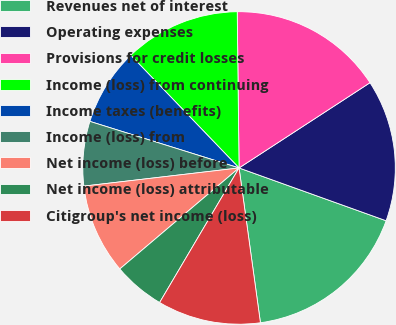Convert chart. <chart><loc_0><loc_0><loc_500><loc_500><pie_chart><fcel>Revenues net of interest<fcel>Operating expenses<fcel>Provisions for credit losses<fcel>Income (loss) from continuing<fcel>Income taxes (benefits)<fcel>Income (loss) from<fcel>Net income (loss) before<fcel>Net income (loss) attributable<fcel>Citigroup's net income (loss)<nl><fcel>17.33%<fcel>14.67%<fcel>16.0%<fcel>12.0%<fcel>8.0%<fcel>6.67%<fcel>9.33%<fcel>5.33%<fcel>10.67%<nl></chart> 